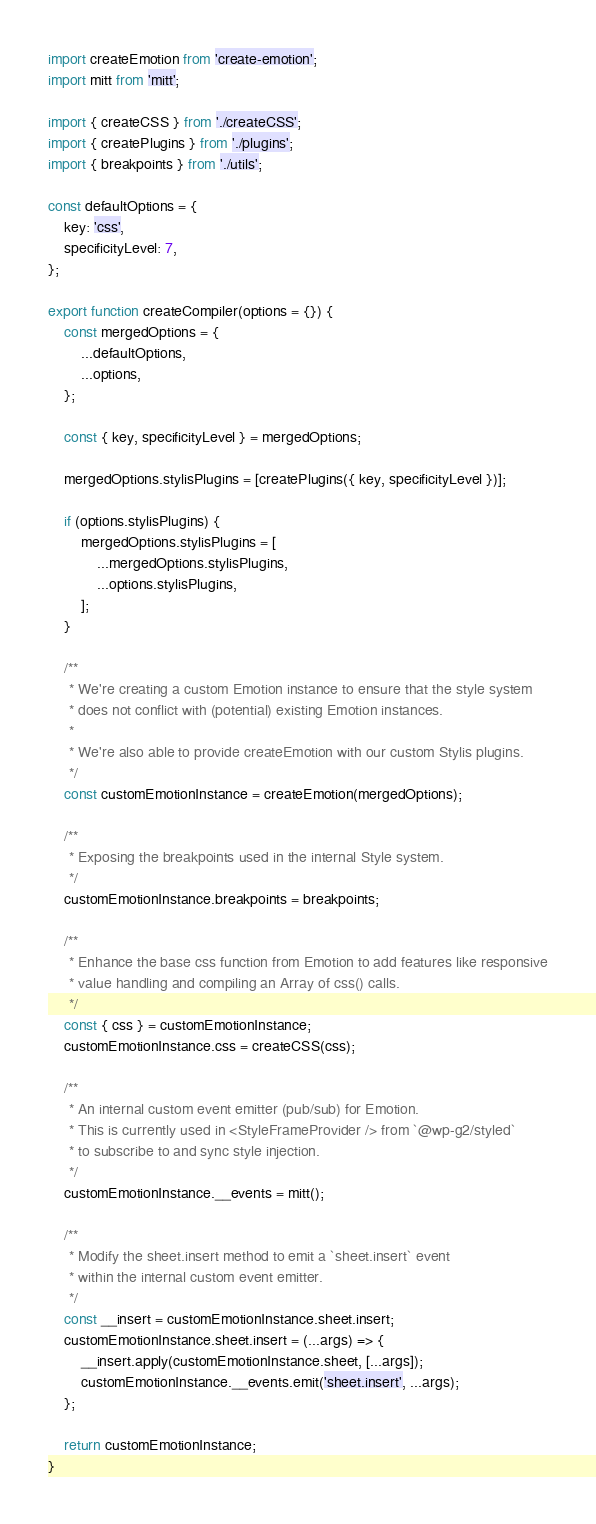Convert code to text. <code><loc_0><loc_0><loc_500><loc_500><_JavaScript_>import createEmotion from 'create-emotion';
import mitt from 'mitt';

import { createCSS } from './createCSS';
import { createPlugins } from './plugins';
import { breakpoints } from './utils';

const defaultOptions = {
	key: 'css',
	specificityLevel: 7,
};

export function createCompiler(options = {}) {
	const mergedOptions = {
		...defaultOptions,
		...options,
	};

	const { key, specificityLevel } = mergedOptions;

	mergedOptions.stylisPlugins = [createPlugins({ key, specificityLevel })];

	if (options.stylisPlugins) {
		mergedOptions.stylisPlugins = [
			...mergedOptions.stylisPlugins,
			...options.stylisPlugins,
		];
	}

	/**
	 * We're creating a custom Emotion instance to ensure that the style system
	 * does not conflict with (potential) existing Emotion instances.
	 *
	 * We're also able to provide createEmotion with our custom Stylis plugins.
	 */
	const customEmotionInstance = createEmotion(mergedOptions);

	/**
	 * Exposing the breakpoints used in the internal Style system.
	 */
	customEmotionInstance.breakpoints = breakpoints;

	/**
	 * Enhance the base css function from Emotion to add features like responsive
	 * value handling and compiling an Array of css() calls.
	 */
	const { css } = customEmotionInstance;
	customEmotionInstance.css = createCSS(css);

	/**
	 * An internal custom event emitter (pub/sub) for Emotion.
	 * This is currently used in <StyleFrameProvider /> from `@wp-g2/styled`
	 * to subscribe to and sync style injection.
	 */
	customEmotionInstance.__events = mitt();

	/**
	 * Modify the sheet.insert method to emit a `sheet.insert` event
	 * within the internal custom event emitter.
	 */
	const __insert = customEmotionInstance.sheet.insert;
	customEmotionInstance.sheet.insert = (...args) => {
		__insert.apply(customEmotionInstance.sheet, [...args]);
		customEmotionInstance.__events.emit('sheet.insert', ...args);
	};

	return customEmotionInstance;
}
</code> 